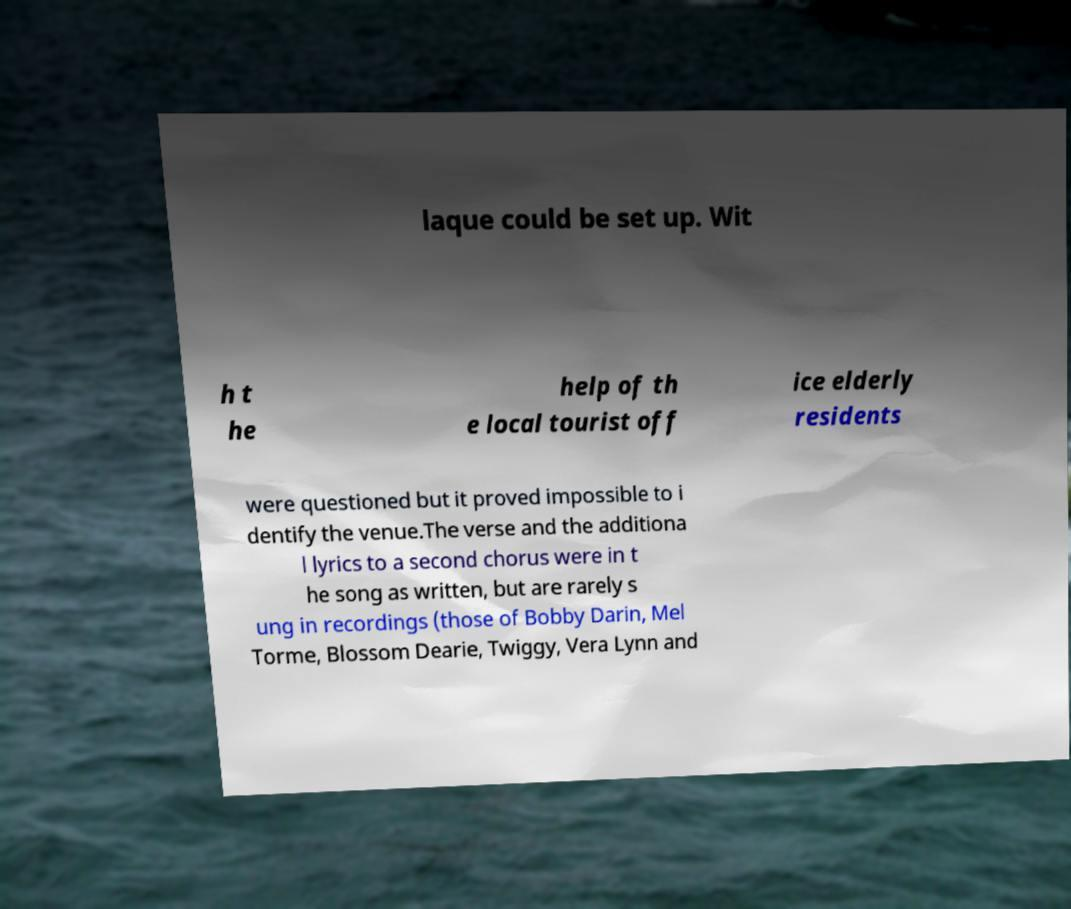I need the written content from this picture converted into text. Can you do that? laque could be set up. Wit h t he help of th e local tourist off ice elderly residents were questioned but it proved impossible to i dentify the venue.The verse and the additiona l lyrics to a second chorus were in t he song as written, but are rarely s ung in recordings (those of Bobby Darin, Mel Torme, Blossom Dearie, Twiggy, Vera Lynn and 